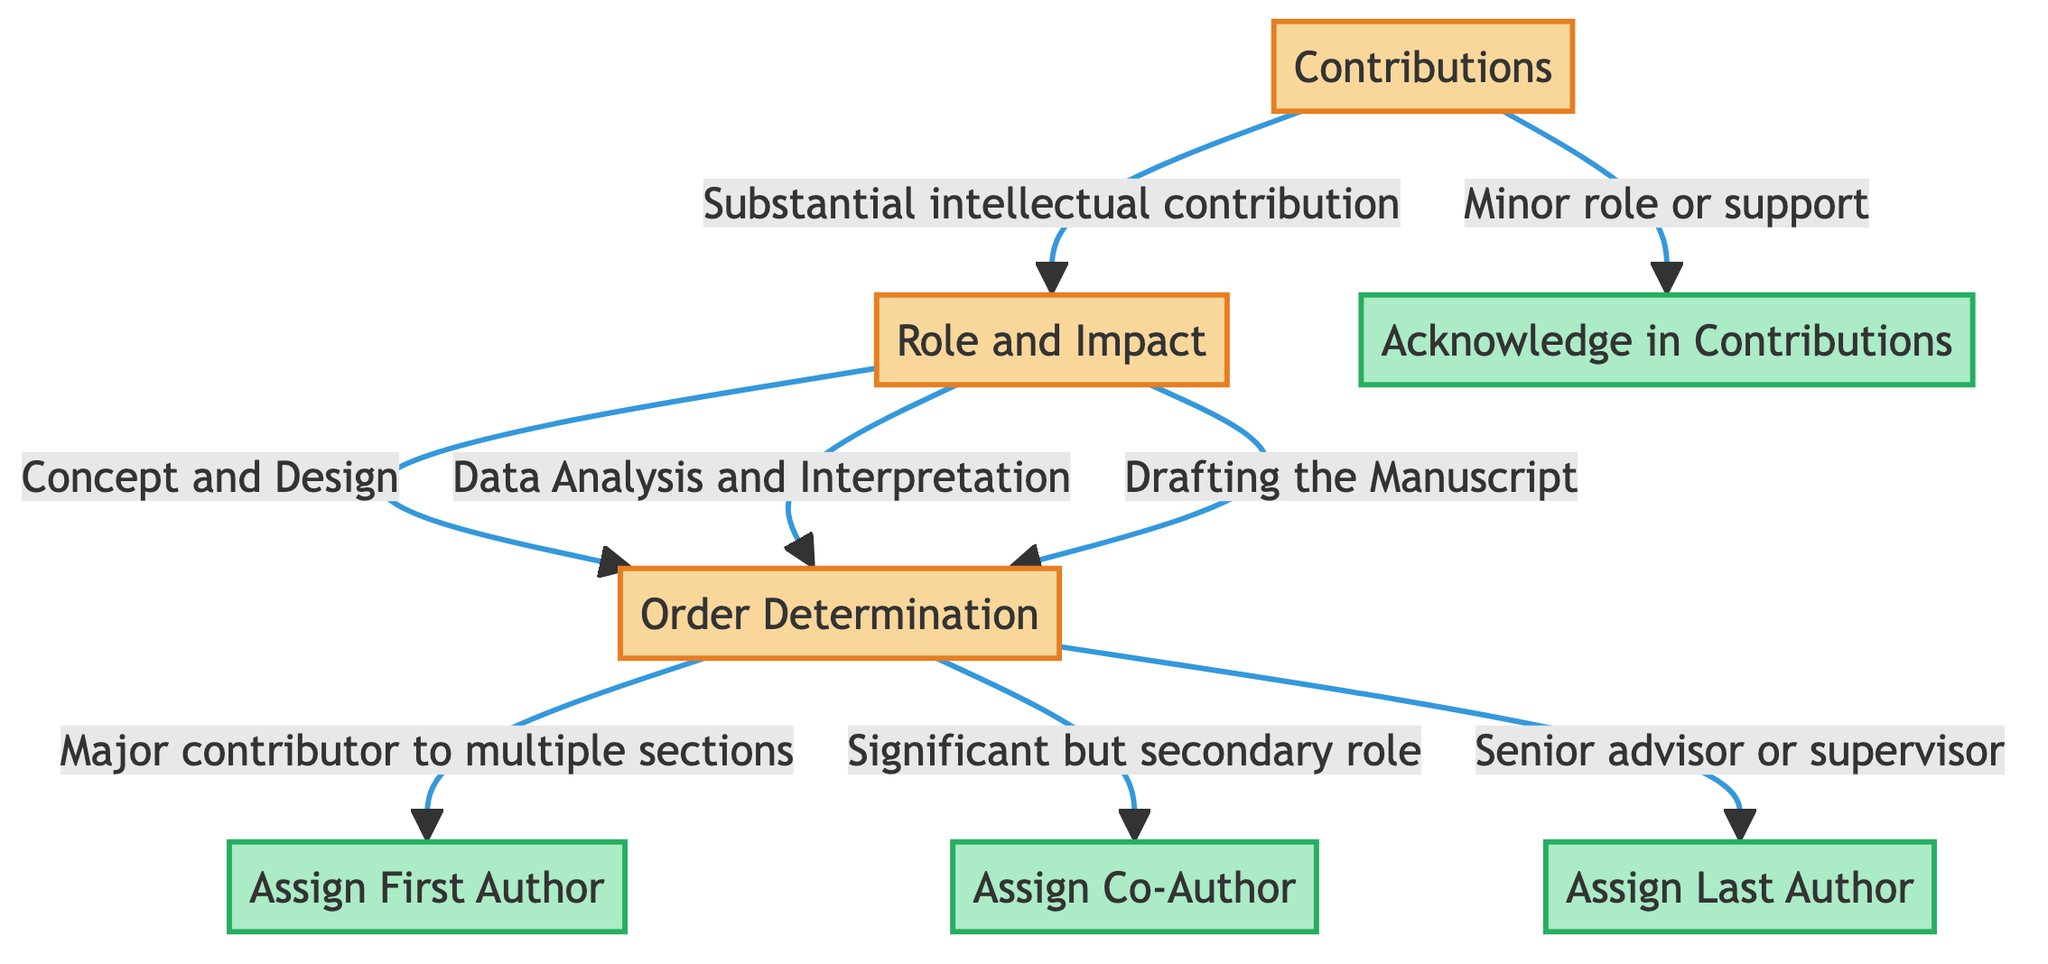What is the first decision point in the diagram? The diagram starts with the "Contributions" decision, which is the first node in the flow.
Answer: Contributions How many options are there for the "Role and Impact" decision? The "Role and Impact" decision has three options: "Concept and Design", "Data Analysis and Interpretation", and "Drafting the Manuscript".
Answer: 3 What is the outcome if the "Substantial intellectual contribution" is selected? Selecting "Substantial intellectual contribution" leads to the next decision point "Role and Impact" in the flow.
Answer: Role and Impact If a researcher made a significant but secondary role contribution, what would the final action be? The "Significant but secondary role" leads to the action "Assign Co-Author", which is the outcome based on that contribution level.
Answer: Assign Co-Author What happens if someone is classified as a "Senior advisor or supervisor"? Being classified as a "Senior advisor or supervisor" leads directly to "Assign Last Author", indicating their place in the authorship order.
Answer: Assign Last Author How many terminal nodes are in the diagram? The diagram contains four terminal nodes: "Assign First Author", "Assign Co-Author", "Assign Last Author", and "Acknowledge in Contributions".
Answer: 4 What is the relationship between "Concept and Design" and "Assign First Author"? "Concept and Design" is a pathway that connects through "Order Determination" to the outcome "Assign First Author".
Answer: Pathway Which decision leads to "Acknowledge in Contributions"? The decision for "Minor role or support" directly leads to the terminal action "Acknowledge in Contributions", highlighting a less significant contribution.
Answer: Minor role or support 